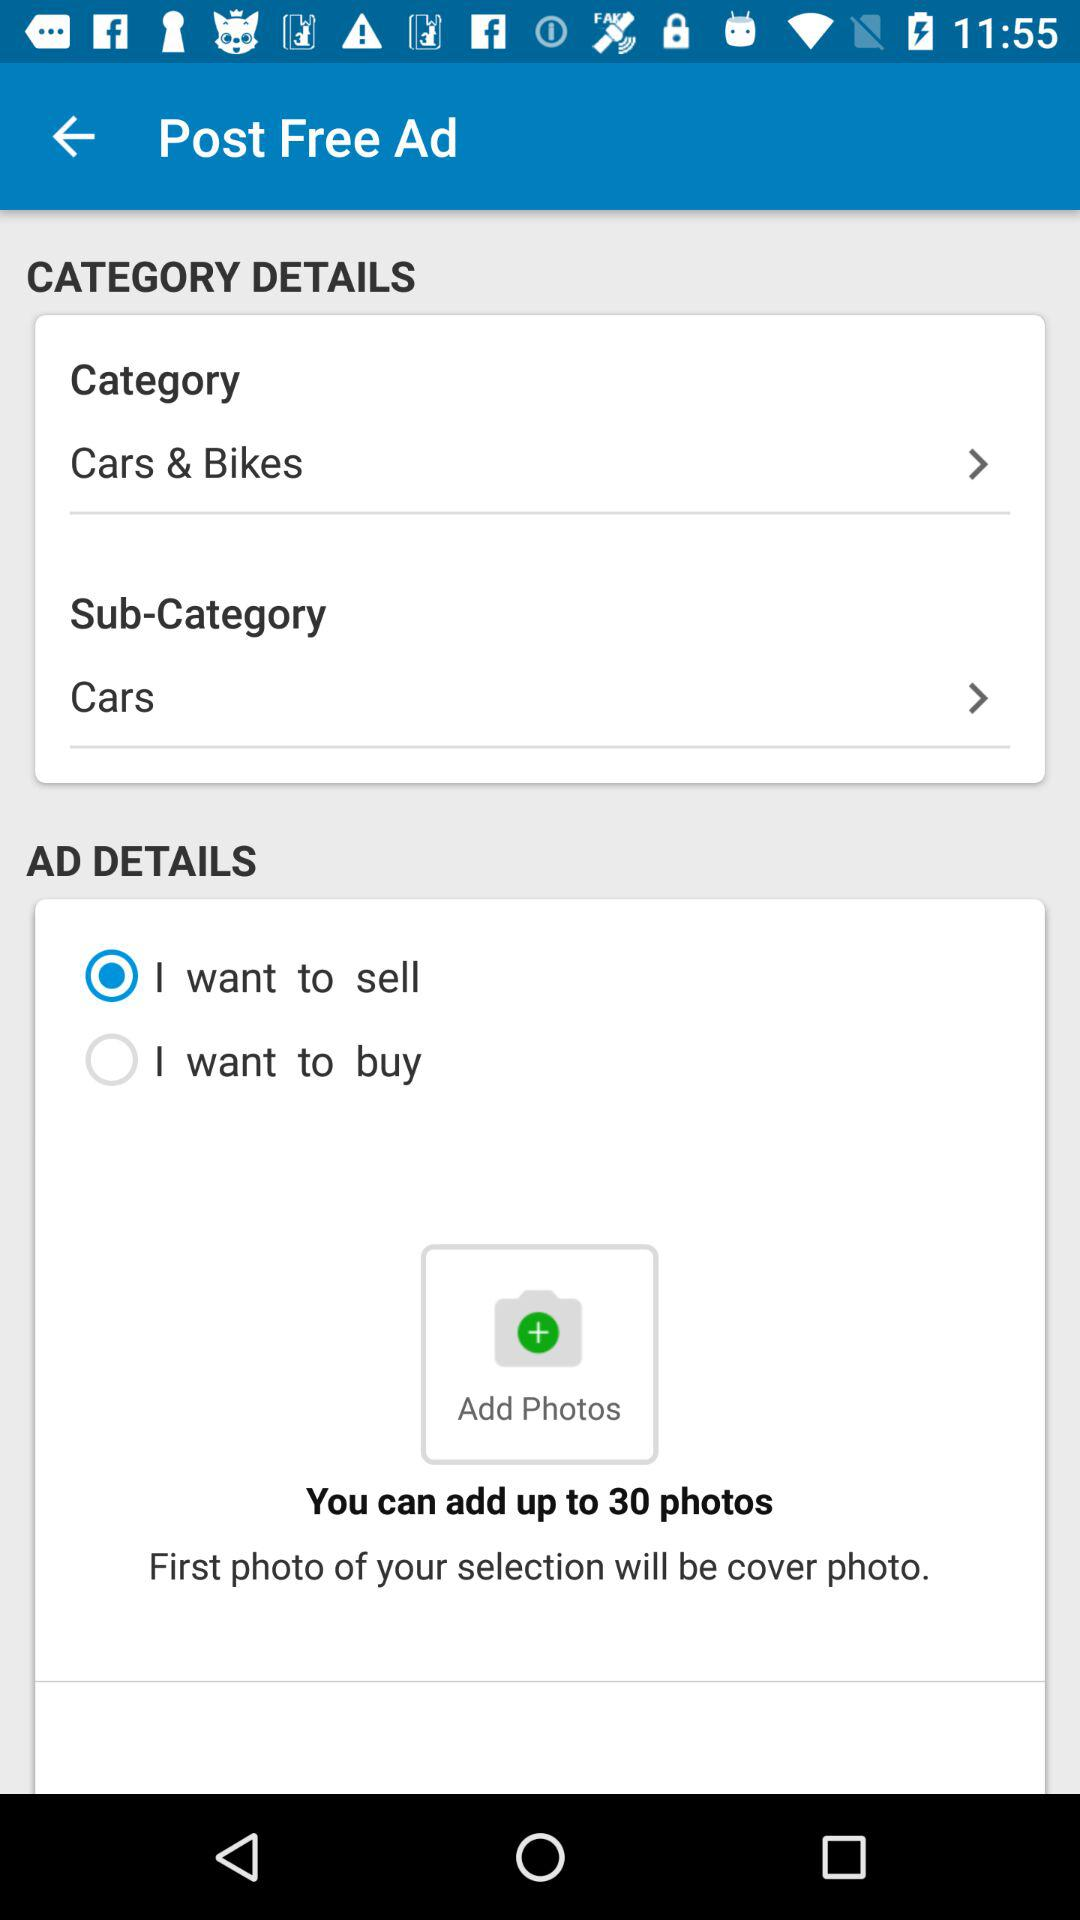Which sub-category is selected? The selected sub-category is "Cars". 